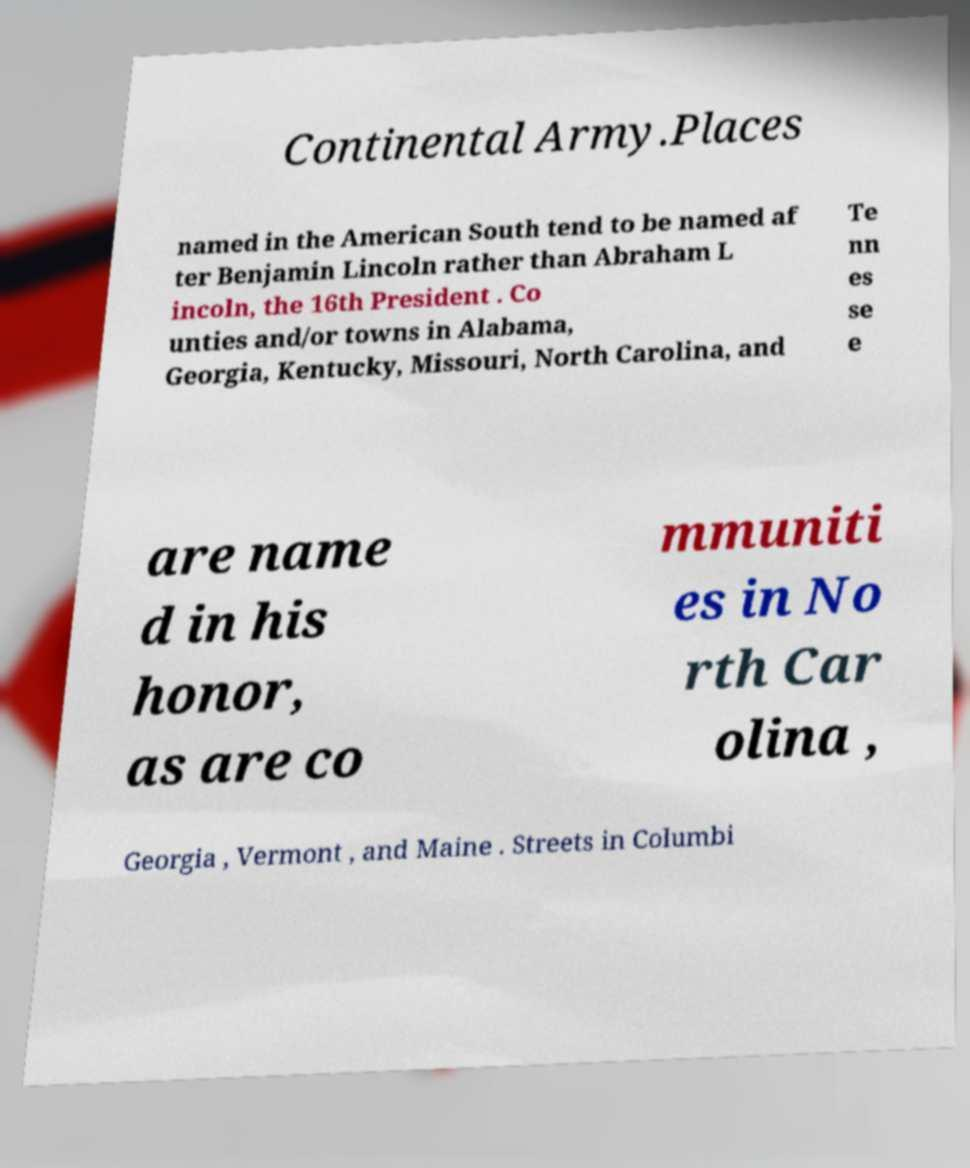Could you extract and type out the text from this image? Continental Army.Places named in the American South tend to be named af ter Benjamin Lincoln rather than Abraham L incoln, the 16th President . Co unties and/or towns in Alabama, Georgia, Kentucky, Missouri, North Carolina, and Te nn es se e are name d in his honor, as are co mmuniti es in No rth Car olina , Georgia , Vermont , and Maine . Streets in Columbi 